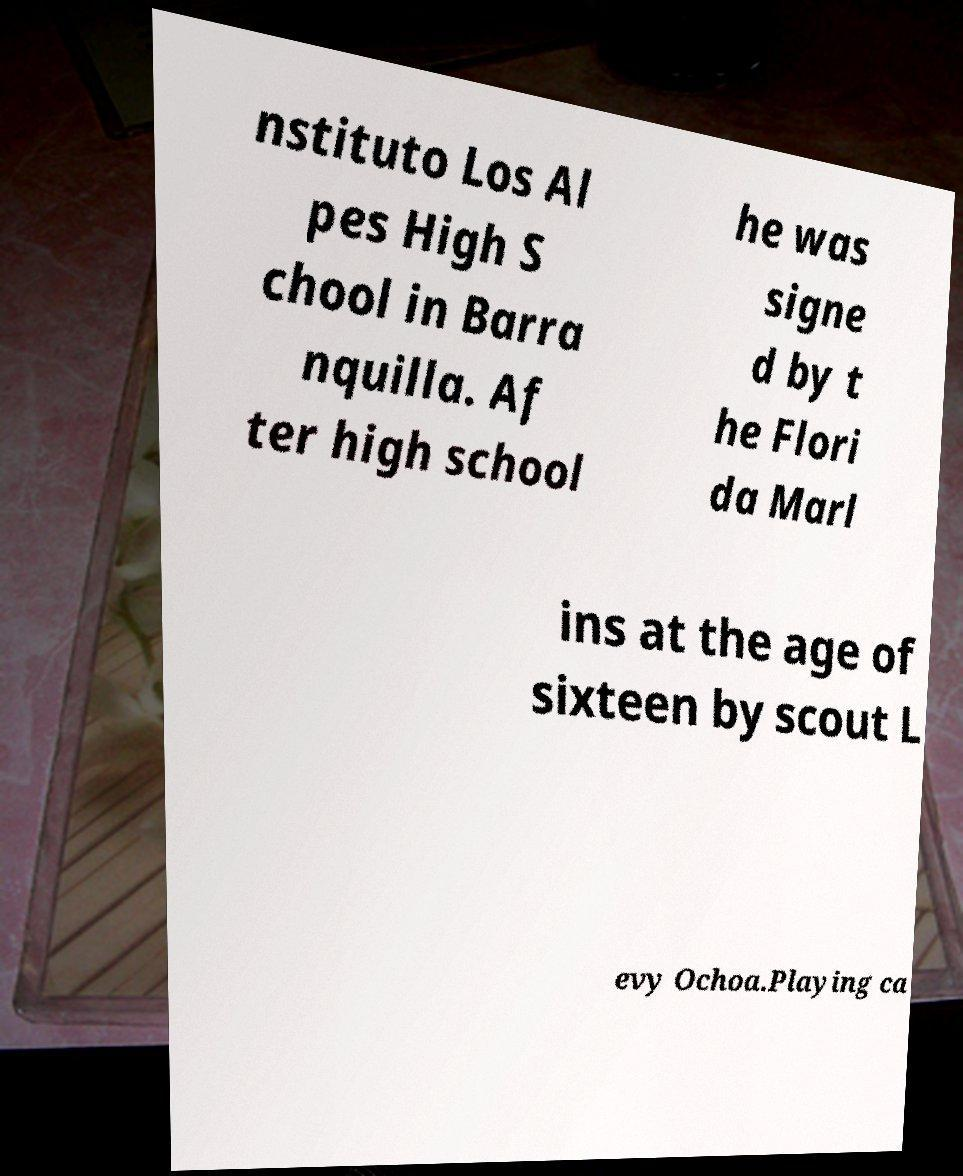Can you read and provide the text displayed in the image?This photo seems to have some interesting text. Can you extract and type it out for me? nstituto Los Al pes High S chool in Barra nquilla. Af ter high school he was signe d by t he Flori da Marl ins at the age of sixteen by scout L evy Ochoa.Playing ca 